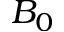<formula> <loc_0><loc_0><loc_500><loc_500>B _ { 0 }</formula> 